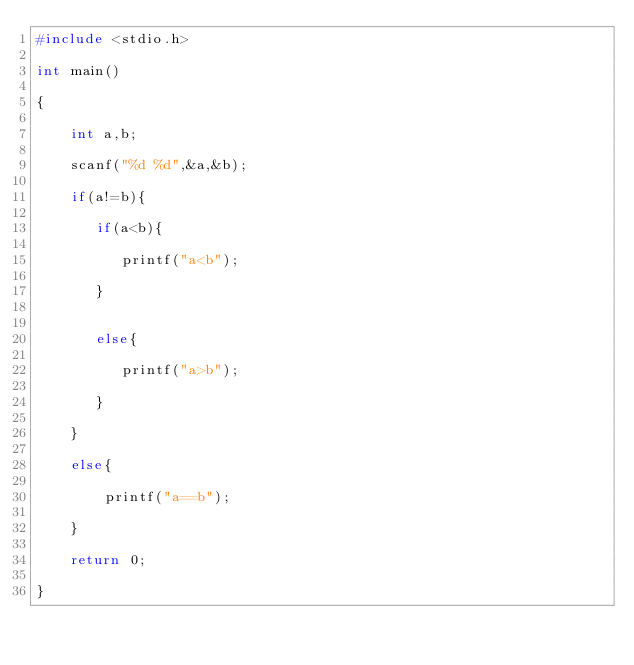<code> <loc_0><loc_0><loc_500><loc_500><_C_>#include <stdio.h>

int main()

{     

    int a,b;

    scanf("%d %d",&a,&b);

    if(a!=b){

       if(a<b){

          printf("a<b");

       }


       else{

          printf("a>b");

       }

    }

    else{

        printf("a==b");

    }

    return 0;

}</code> 